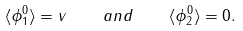<formula> <loc_0><loc_0><loc_500><loc_500>\langle \phi _ { 1 } ^ { 0 } \rangle = v \quad a n d \quad \langle \phi _ { 2 } ^ { 0 } \rangle = 0 .</formula> 